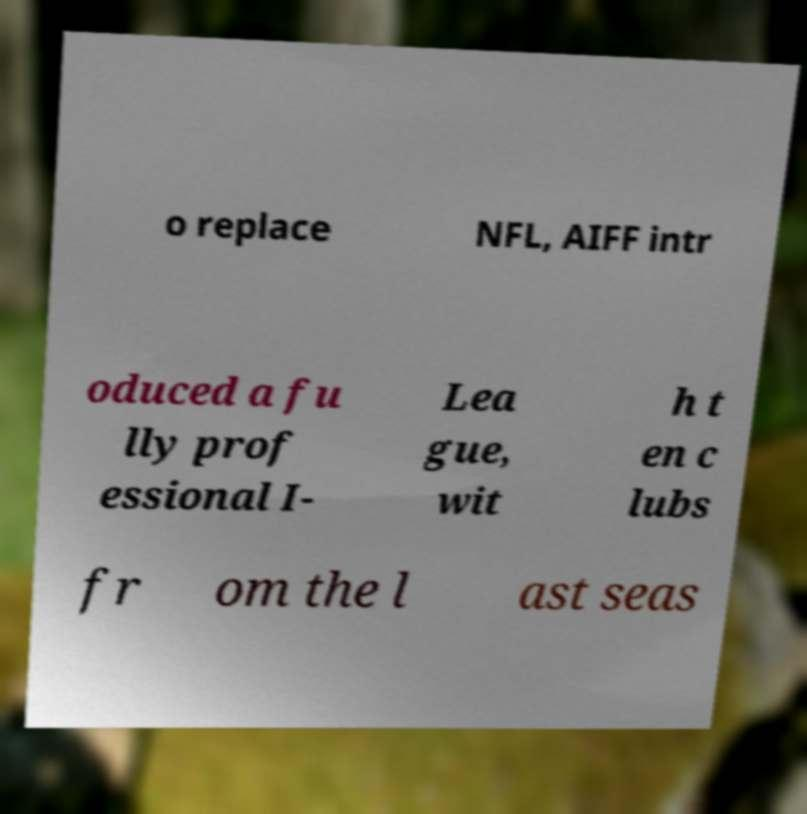Could you extract and type out the text from this image? o replace NFL, AIFF intr oduced a fu lly prof essional I- Lea gue, wit h t en c lubs fr om the l ast seas 